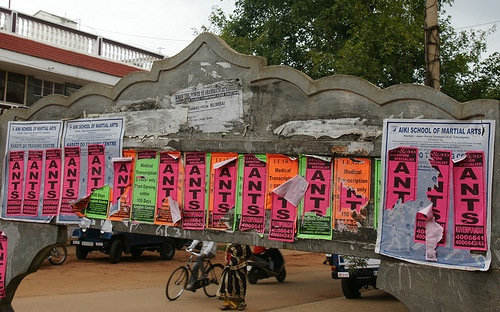Describe the objects in this image and their specific colors. I can see car in white, black, gray, maroon, and darkgray tones, people in white, black, maroon, and gray tones, bicycle in white, black, gray, and maroon tones, truck in white, black, darkgray, gray, and maroon tones, and motorcycle in white, black, maroon, and gray tones in this image. 